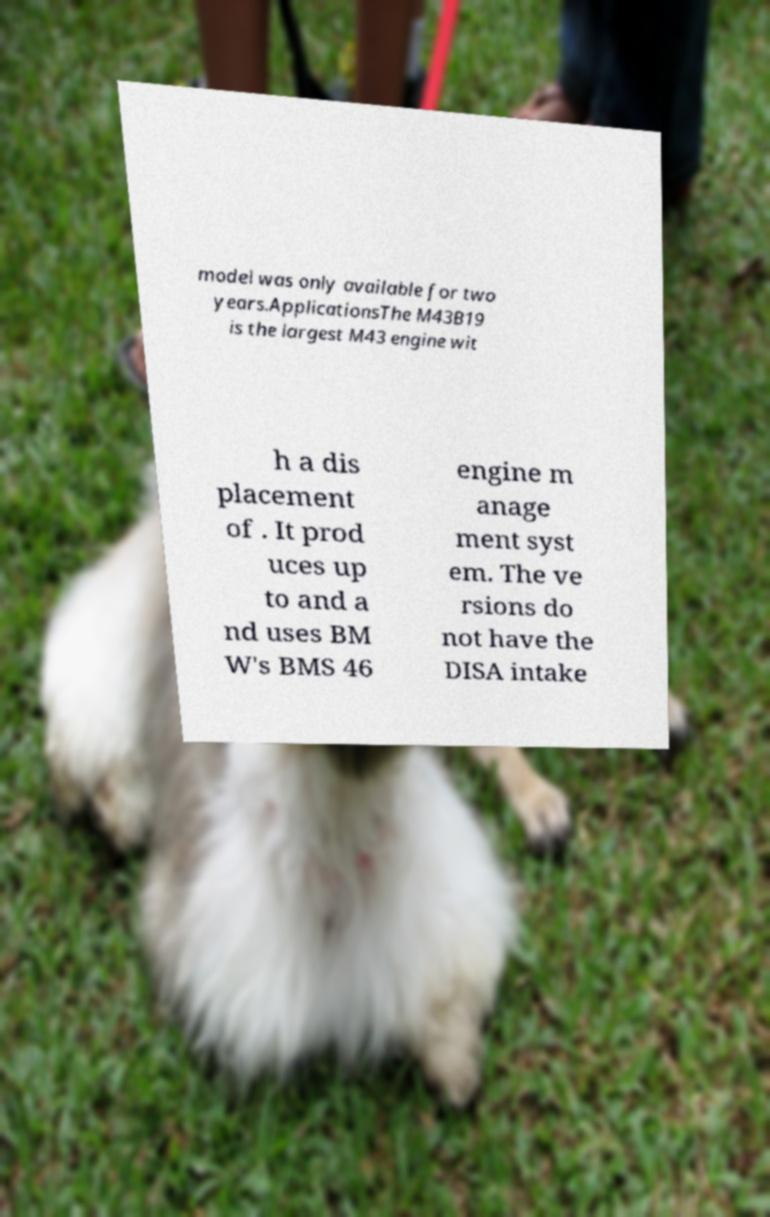For documentation purposes, I need the text within this image transcribed. Could you provide that? model was only available for two years.ApplicationsThe M43B19 is the largest M43 engine wit h a dis placement of . It prod uces up to and a nd uses BM W's BMS 46 engine m anage ment syst em. The ve rsions do not have the DISA intake 